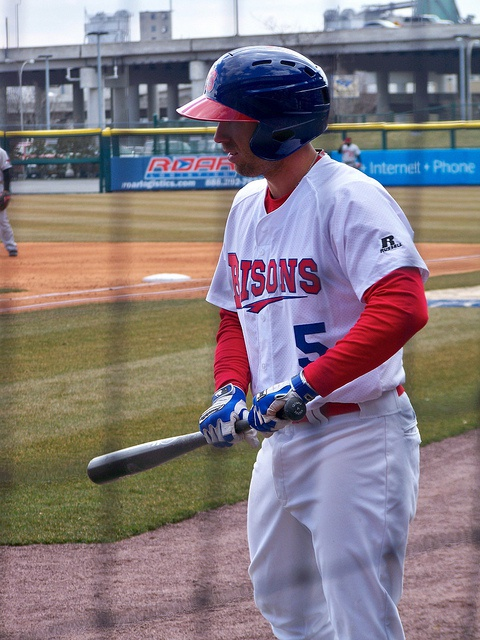Describe the objects in this image and their specific colors. I can see people in white, darkgray, gray, and lavender tones, baseball bat in white, black, gray, and darkgray tones, people in white, gray, and black tones, and people in white, gray, and darkgray tones in this image. 